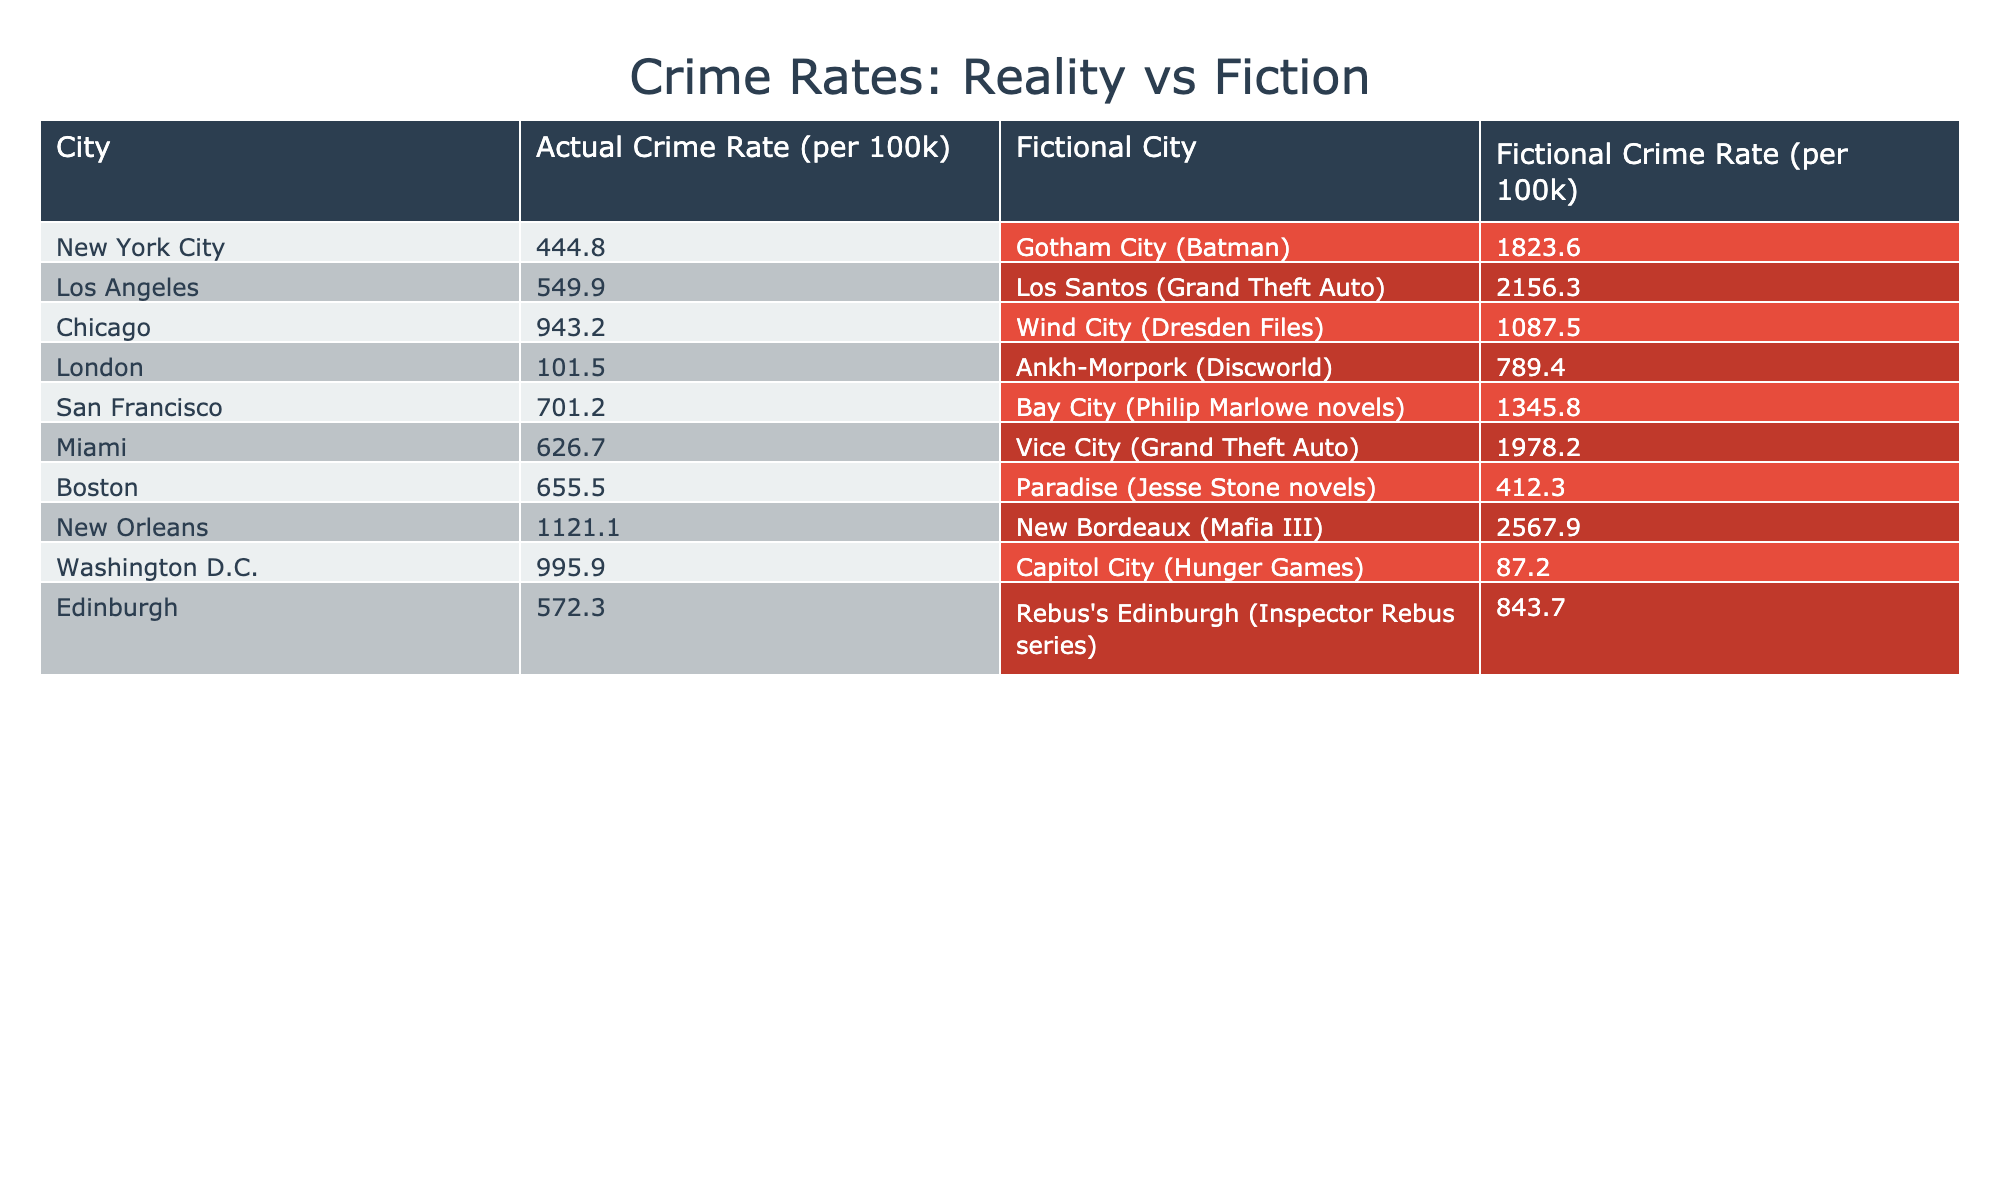What is the crime rate in New York City? The table lists the actual crime rate in New York City as 444.8 per 100k.
Answer: 444.8 Which fictional city has the highest crime rate? Comparing the fictional crime rates, New Bordeaux from Mafia III has the highest rate at 2567.9 per 100k.
Answer: New Bordeaux Is the crime rate in Los Santos higher than in Miami? The crime rate in Los Santos is 2156.3 per 100k, while in Miami it is 626.7 per 100k, making Los Santos significantly higher.
Answer: Yes What is the difference in crime rates between Gotham City and Chicago's Wind City? The crime rate in Gotham City is 1823.6, while Wind City has a rate of 1087.5. The difference is 1823.6 - 1087.5 = 736.1.
Answer: 736.1 What is the average fictional crime rate among the listed fictional cities? To find the average, sum the fictional crime rates (1823.6 + 2156.3 + 1087.5 + 789.4 + 1345.8 + 1978.2 + 412.3 + 2567.9) which equals 11670.0 and divide by the number of cities (8), so 11670.0 / 8 = 1458.75.
Answer: 1458.75 Is the fictional crime rate in Capitol City lower than that in actual Washington D.C.? The fictional crime rate in Capitol City is 87.2, which is much lower than the actual rate of 995.9 in Washington D.C.
Answer: Yes Which city shows the most drastic increase in crime rate when comparing actual and fictional crime rates? To determine the most drastic increase, compare the differences: Gotham City (1823.6 - 444.8 = 1378.8), Los Santos (2156.3 - 549.9 = 1606.4), Wind City (1087.5 - 943.2 = 144.3), Bay City (1345.8 - 701.2 = 644.6), Vice City, Paradise, New Bordeaux, Capitol City, and Rebus's Edinburgh. The largest difference is Los Santos with an increase of 1606.4.
Answer: Los Santos How does the crime rate in Edinburgh compare to its fictional counterpart? The actual crime rate in Edinburgh is 572.3, and its fictional counterpart (Rebus's Edinburgh) has a rate of 843.7. Rebus's Edinburgh is higher by 843.7 - 572.3 = 271.4.
Answer: Higher by 271.4 What percentage more is the crime rate in Vice City compared to Boston's Paradise? The crime rate in Vice City is 1978.2 and Paradise is 412.3. The percentage increase is ((1978.2 - 412.3) / 412.3) * 100 = 378.6%.
Answer: 378.6% 